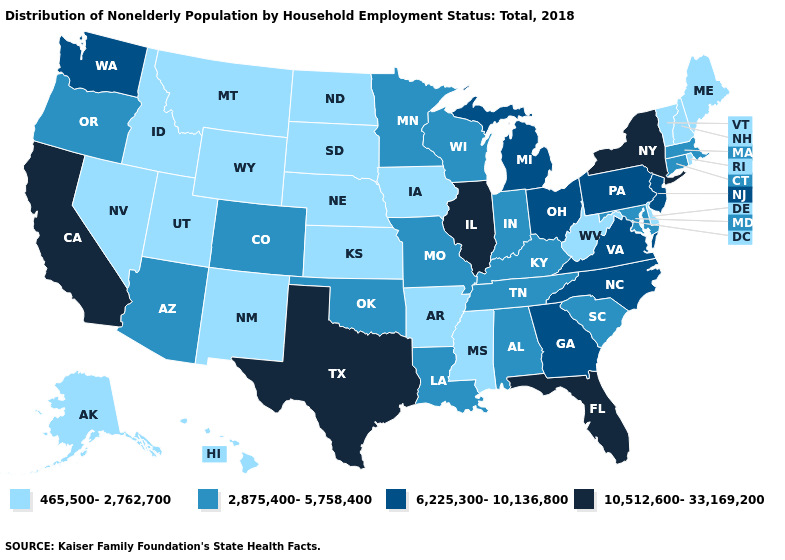What is the highest value in the MidWest ?
Give a very brief answer. 10,512,600-33,169,200. What is the value of Connecticut?
Concise answer only. 2,875,400-5,758,400. Is the legend a continuous bar?
Concise answer only. No. Among the states that border Ohio , does West Virginia have the lowest value?
Keep it brief. Yes. Among the states that border Illinois , does Iowa have the highest value?
Answer briefly. No. What is the lowest value in the USA?
Short answer required. 465,500-2,762,700. Among the states that border Mississippi , does Arkansas have the highest value?
Answer briefly. No. What is the value of Iowa?
Keep it brief. 465,500-2,762,700. How many symbols are there in the legend?
Write a very short answer. 4. What is the highest value in the USA?
Give a very brief answer. 10,512,600-33,169,200. Name the states that have a value in the range 2,875,400-5,758,400?
Answer briefly. Alabama, Arizona, Colorado, Connecticut, Indiana, Kentucky, Louisiana, Maryland, Massachusetts, Minnesota, Missouri, Oklahoma, Oregon, South Carolina, Tennessee, Wisconsin. Does Tennessee have a lower value than Maryland?
Answer briefly. No. What is the value of New Jersey?
Give a very brief answer. 6,225,300-10,136,800. Among the states that border Nevada , does California have the highest value?
Write a very short answer. Yes. What is the highest value in states that border Mississippi?
Answer briefly. 2,875,400-5,758,400. 